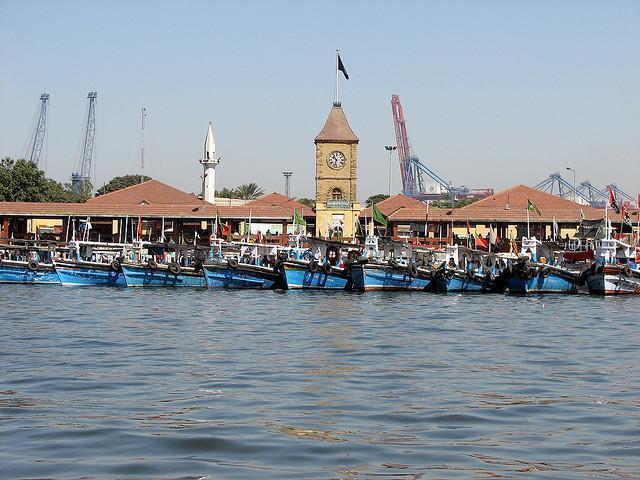What except for a flag are the highest emanations coming from here?
Select the correct answer and articulate reasoning with the following format: 'Answer: answer
Rationale: rationale.'
Options: Homes, cranes, boats, bridges. Answer: cranes.
Rationale: There are several tall cranes in the background that are higher than everything else. 